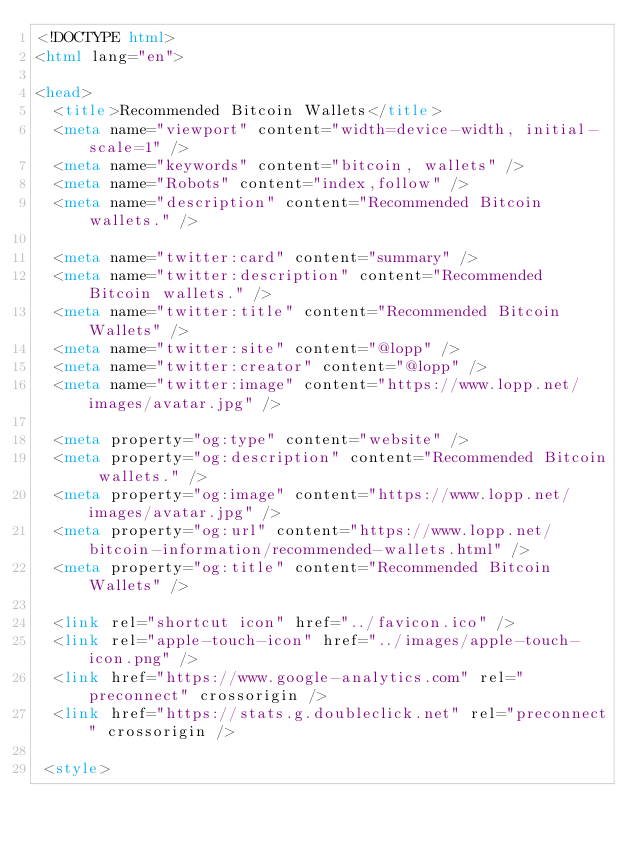Convert code to text. <code><loc_0><loc_0><loc_500><loc_500><_HTML_><!DOCTYPE html>
<html lang="en">

<head>
  <title>Recommended Bitcoin Wallets</title>
  <meta name="viewport" content="width=device-width, initial-scale=1" />
  <meta name="keywords" content="bitcoin, wallets" />
  <meta name="Robots" content="index,follow" />
  <meta name="description" content="Recommended Bitcoin wallets." />

  <meta name="twitter:card" content="summary" />
  <meta name="twitter:description" content="Recommended Bitcoin wallets." />
  <meta name="twitter:title" content="Recommended Bitcoin Wallets" />
  <meta name="twitter:site" content="@lopp" />
  <meta name="twitter:creator" content="@lopp" />
  <meta name="twitter:image" content="https://www.lopp.net/images/avatar.jpg" />

  <meta property="og:type" content="website" />
  <meta property="og:description" content="Recommended Bitcoin wallets." />
  <meta property="og:image" content="https://www.lopp.net/images/avatar.jpg" />
  <meta property="og:url" content="https://www.lopp.net/bitcoin-information/recommended-wallets.html" />
  <meta property="og:title" content="Recommended Bitcoin Wallets" />

  <link rel="shortcut icon" href="../favicon.ico" />
  <link rel="apple-touch-icon" href="../images/apple-touch-icon.png" />
  <link href="https://www.google-analytics.com" rel="preconnect" crossorigin />
  <link href="https://stats.g.doubleclick.net" rel="preconnect" crossorigin />

 <style></code> 